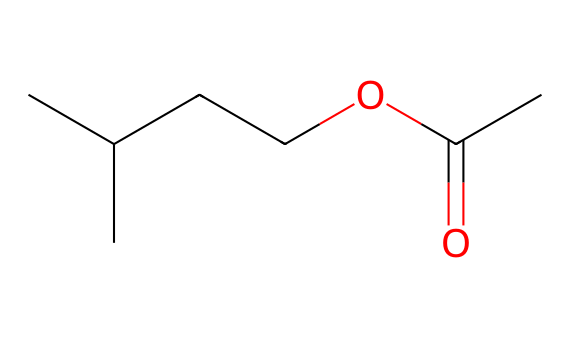What is the name of this chemical? The chemical is isoamyl acetate, which is indicated by its common name and is known for its banana-like scent.
Answer: isoamyl acetate How many carbon atoms are present in the structure? By counting the "C" symbols in the SMILES representation, there are 5 carbon atoms connected in the structure.
Answer: 5 What functional group is present in this chemical? The structure includes an ester functional group, identified by the "OC(=O)" part, which represents the carbonyl and alkoxy groups connecting through oxygen.
Answer: ester What characteristic scent does this chemical give off? This compound is known for having a banana-like scent, which is associated with its molecular structure and is widely recognized.
Answer: banana Is there a cyclic structure in this chemical? Looking at the SMILES representation and its structure, there are no indications of cyclic arrangements, as it consists of a linear arrangement of atoms.
Answer: no Which part of the molecule is responsible for its flavor? The ester bond, specifically the connection between the alcohol and the acid part of the molecule, contributes to its aromatic flavor profile.
Answer: ester bond What is the total number of hydrogen atoms in the structure? By analyzing the structure, we apply the hydrogen saturation rules: every carbon can typically form four bonds. There are 10 hydrogen atoms filling the remaining valences.
Answer: 10 